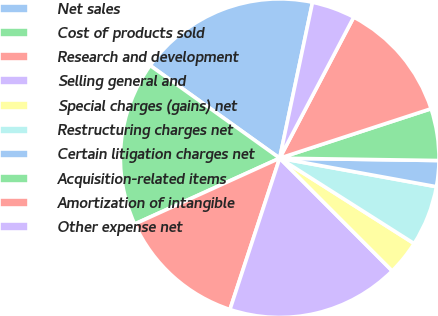<chart> <loc_0><loc_0><loc_500><loc_500><pie_chart><fcel>Net sales<fcel>Cost of products sold<fcel>Research and development<fcel>Selling general and<fcel>Special charges (gains) net<fcel>Restructuring charges net<fcel>Certain litigation charges net<fcel>Acquisition-related items<fcel>Amortization of intangible<fcel>Other expense net<nl><fcel>18.42%<fcel>16.67%<fcel>13.16%<fcel>17.54%<fcel>3.51%<fcel>6.14%<fcel>2.63%<fcel>5.26%<fcel>12.28%<fcel>4.39%<nl></chart> 